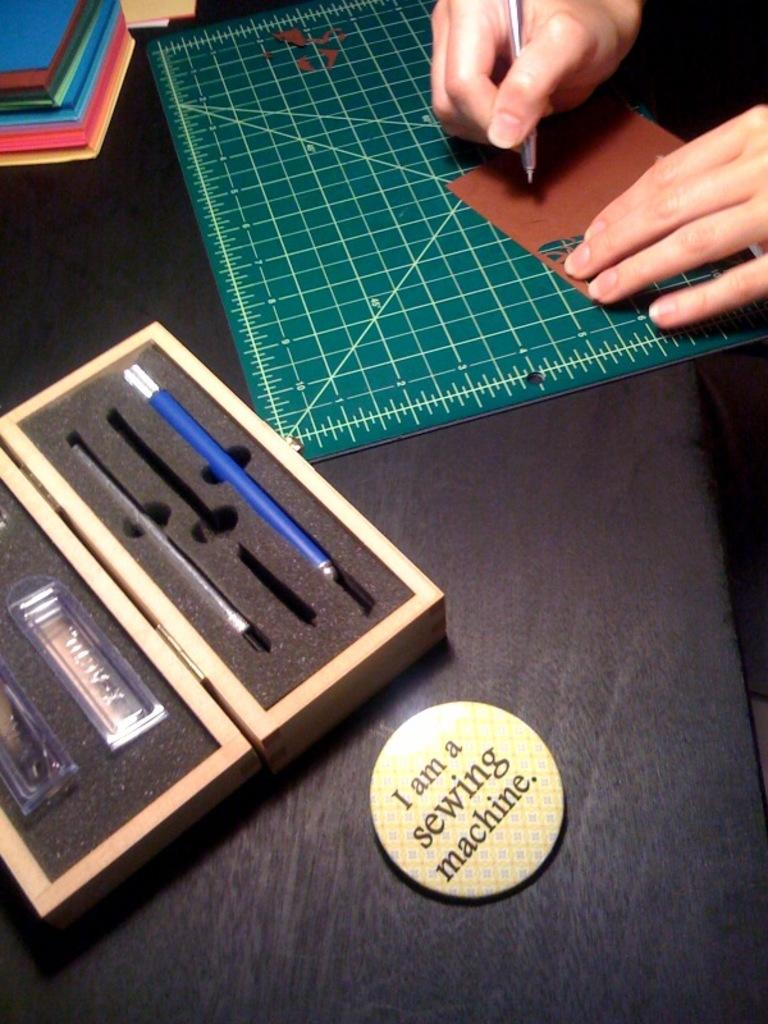<image>
Relay a brief, clear account of the picture shown. A person is tracing something on a board, and they have a bin next to them that says "I am a sewing machine." 